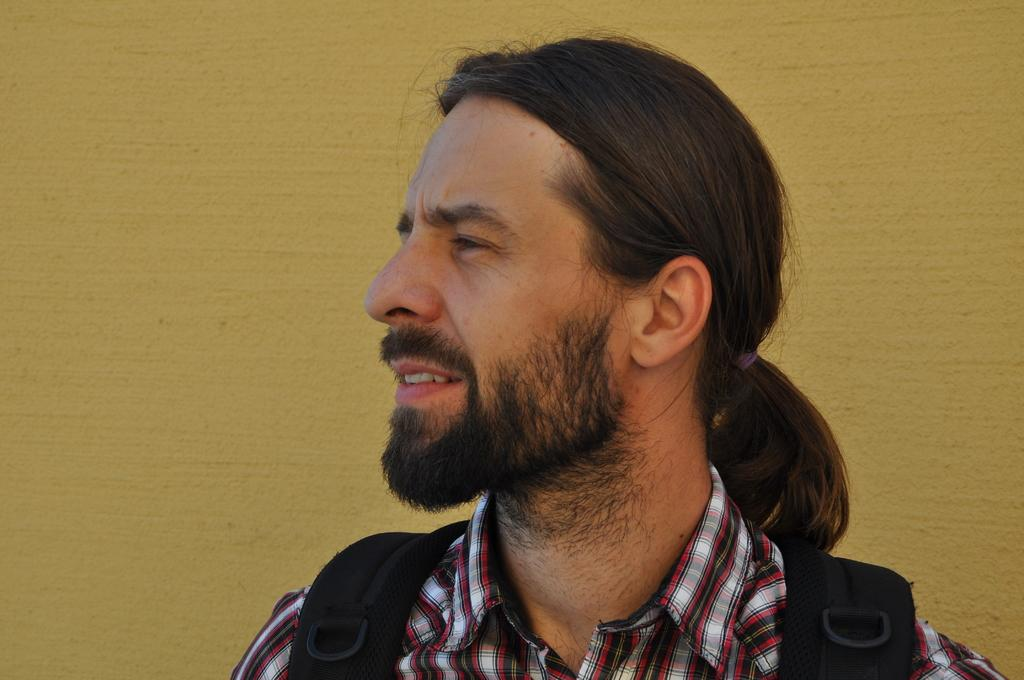Who is present in the image? There is a man in the image. What is the man wearing? The man is wearing a bag. What can be seen in the background of the image? There is a wall in the background of the image. When might this image have been taken? The image was likely taken during the day, as there is no indication of darkness or artificial lighting. Can you see the top of the sea in the image? There is no sea present in the image, so it is not possible to see the top of it. 